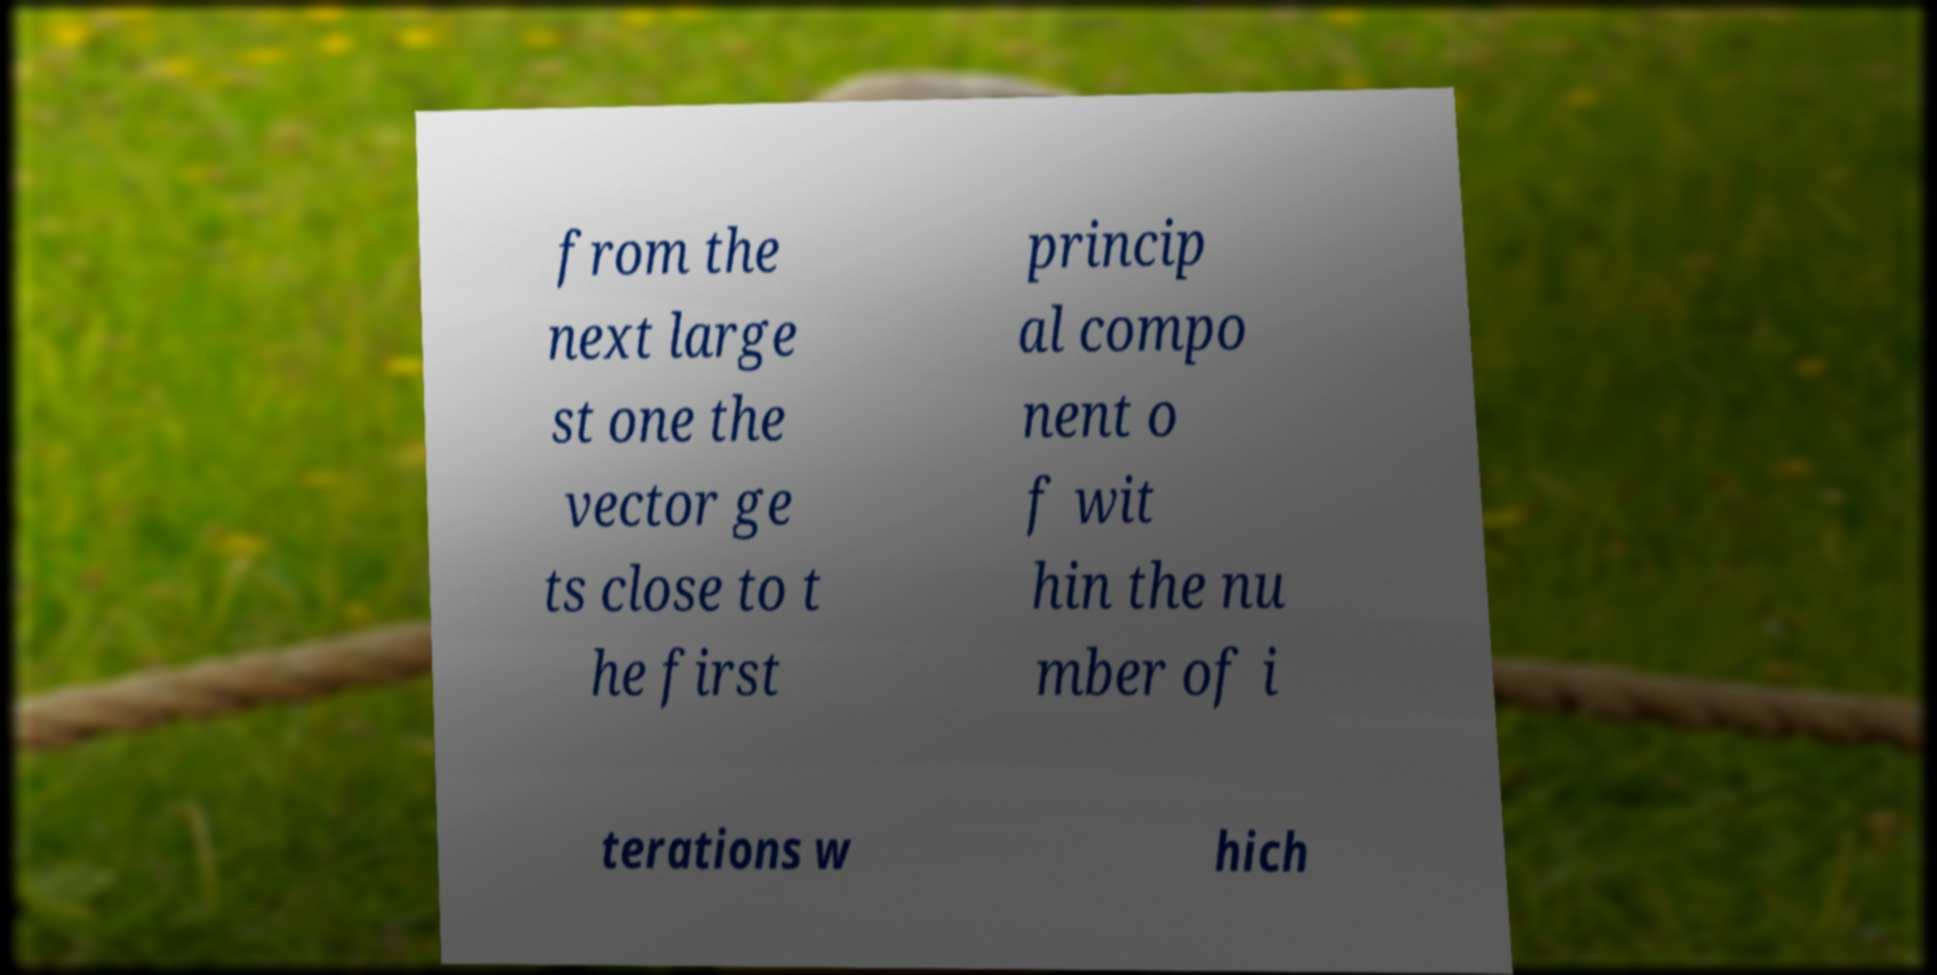Could you extract and type out the text from this image? from the next large st one the vector ge ts close to t he first princip al compo nent o f wit hin the nu mber of i terations w hich 